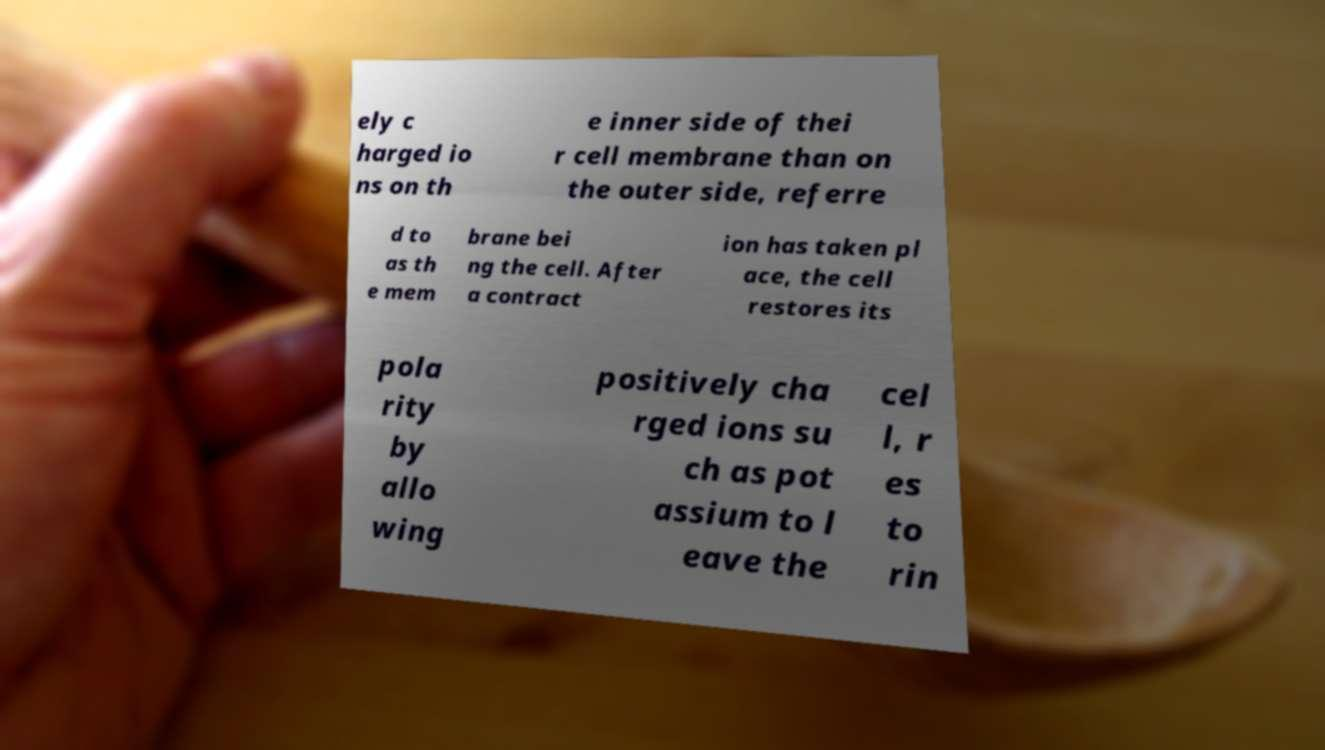There's text embedded in this image that I need extracted. Can you transcribe it verbatim? ely c harged io ns on th e inner side of thei r cell membrane than on the outer side, referre d to as th e mem brane bei ng the cell. After a contract ion has taken pl ace, the cell restores its pola rity by allo wing positively cha rged ions su ch as pot assium to l eave the cel l, r es to rin 